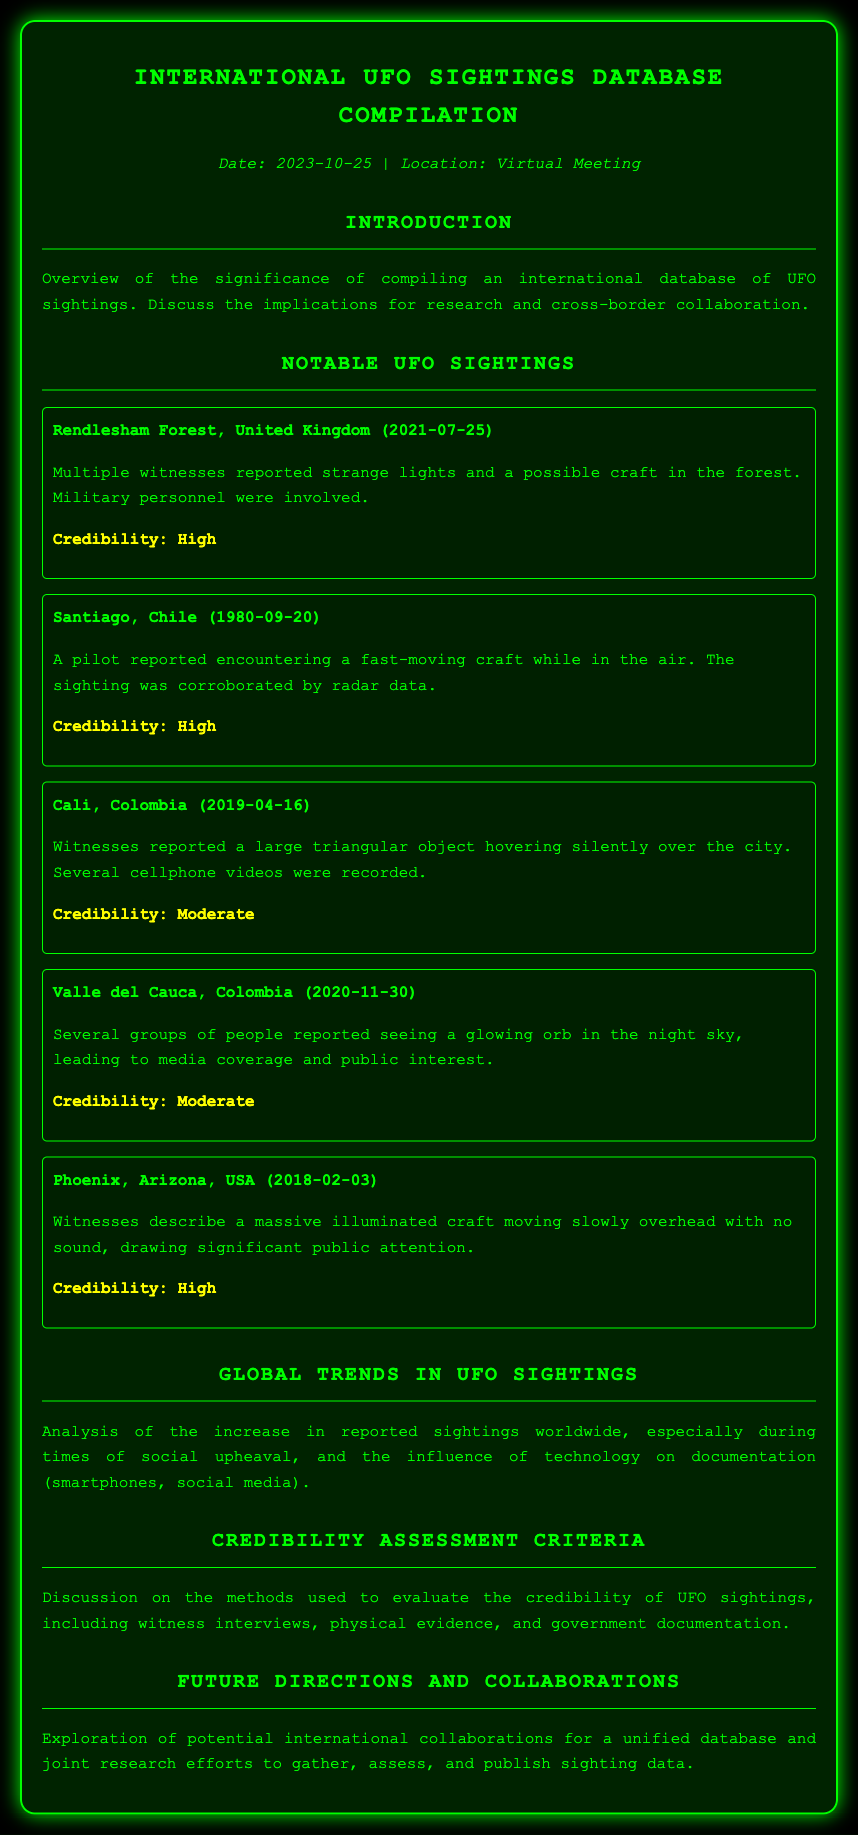what is the title of the document? The title is given in the header of the document as a main heading.
Answer: International UFO Sightings Database Compilation when was the virtual meeting held? The date of the virtual meeting is mentioned in the metadata section.
Answer: 2023-10-25 which country reported the sighting on July 25, 2021? The location of the sighting is specified within the description of notable UFO sightings.
Answer: United Kingdom what type of object was reported in Cali, Colombia on April 16, 2019? The description of the sighting mentions the shape of the object observed by witnesses.
Answer: triangular object what credibility rating was given to the sighting in Phoenix, Arizona on February 3, 2018? The credibility rating is specified below the description of that particular sighting.
Answer: High what trend is analyzed in the document regarding UFO sightings? The analysis section discusses a certain pattern observed in UFO sighting reports.
Answer: increase in reported sightings what is used to evaluate the credibility of UFO sightings? The section on credibility assessment criteria mentions the methods applied for evaluation.
Answer: witness interviews what does the future directions section explore? The summary in this section indicates the focus of future research and collaboration efforts.
Answer: international collaborations 